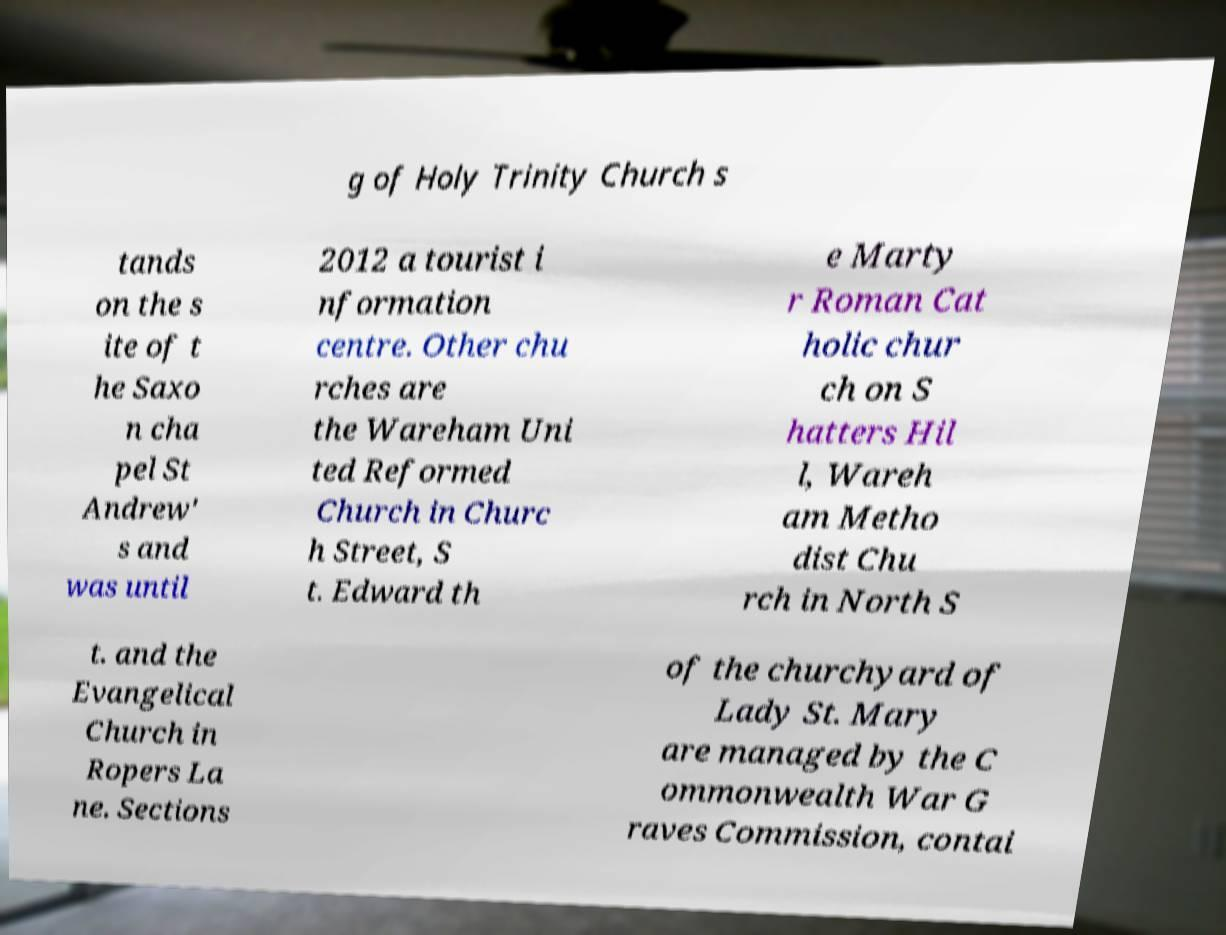Please identify and transcribe the text found in this image. g of Holy Trinity Church s tands on the s ite of t he Saxo n cha pel St Andrew' s and was until 2012 a tourist i nformation centre. Other chu rches are the Wareham Uni ted Reformed Church in Churc h Street, S t. Edward th e Marty r Roman Cat holic chur ch on S hatters Hil l, Wareh am Metho dist Chu rch in North S t. and the Evangelical Church in Ropers La ne. Sections of the churchyard of Lady St. Mary are managed by the C ommonwealth War G raves Commission, contai 